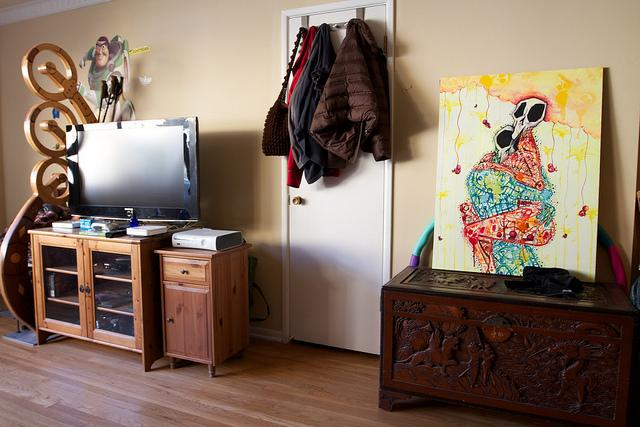What color is the coat jacket on the right side of the rack hung on the white door? Please explain your reasoning. brown. The shade of color is similar to that of dirt or soil. 